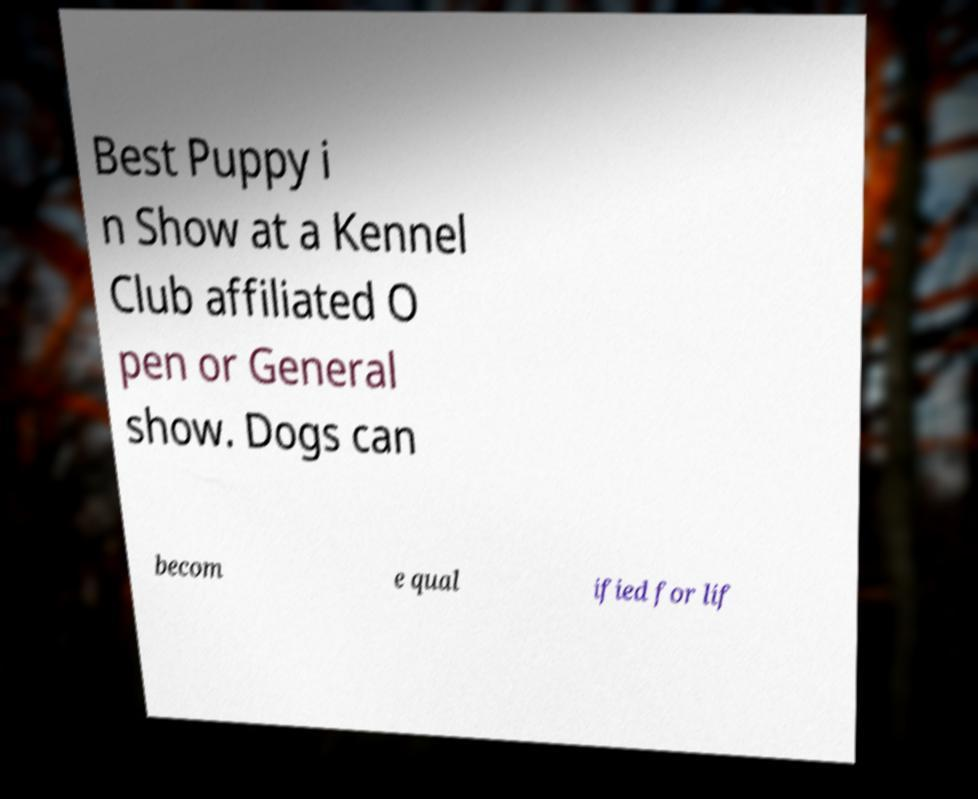What messages or text are displayed in this image? I need them in a readable, typed format. Best Puppy i n Show at a Kennel Club affiliated O pen or General show. Dogs can becom e qual ified for lif 